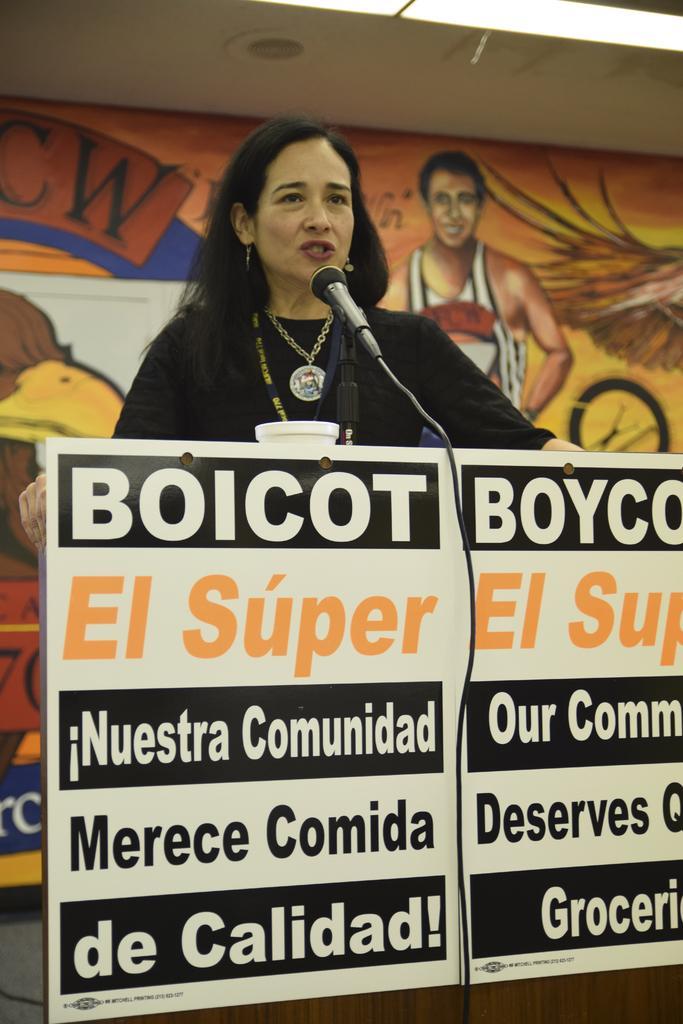How would you summarize this image in a sentence or two? In this image there is a person standing at the table. There is a mike. There is a wall with a painting in the background. 